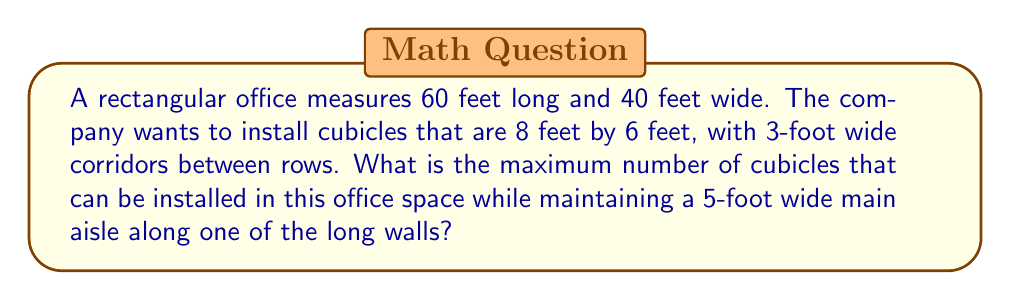Show me your answer to this math problem. Let's approach this step-by-step:

1) First, we need to account for the main aisle:
   60 feet long, 5 feet wide
   Remaining width: $40 - 5 = 35$ feet

2) Now, let's consider the cubicle layout:
   - Each cubicle is 8 feet by 6 feet
   - Corridors between rows are 3 feet wide

3) We can fit cubicles in two orientations:
   a) Long side parallel to the 60-foot wall
   b) Short side parallel to the 60-foot wall

Let's calculate both:

a) Long side parallel:
   - Number of rows: $\lfloor \frac{35}{(6 + 3)} \rfloor = \lfloor \frac{35}{9} \rfloor = 3$ rows
   - Number of cubicles per row: $\lfloor \frac{60}{8} \rfloor = 7$ cubicles
   Total: $3 \times 7 = 21$ cubicles

b) Short side parallel:
   - Number of rows: $\lfloor \frac{35}{(8 + 3)} \rfloor = \lfloor \frac{35}{11} \rfloor = 3$ rows
   - Number of cubicles per row: $\lfloor \frac{60}{6} \rfloor = 10$ cubicles
   Total: $3 \times 10 = 30$ cubicles

4) The maximum number of cubicles is 30, achieved with the short side parallel to the 60-foot wall.

[asy]
unitsize(2.5pt);
draw((0,0)--(60,0)--(60,40)--(0,40)--cycle);
draw((0,35)--(60,35));
for(int i=0; i<3; ++i) {
  for(int j=0; j<10; ++j) {
    draw((j*6,i*11)--((j+1)*6,i*11)--((j+1)*6,(i+1)*11-3)--(j*6,(i+1)*11-3)--cycle);
  }
}
label("60'", (30,-5));
label("40'", (-5,20), W);
label("5'", (62,37.5), E);
[/asy]
Answer: 30 cubicles 